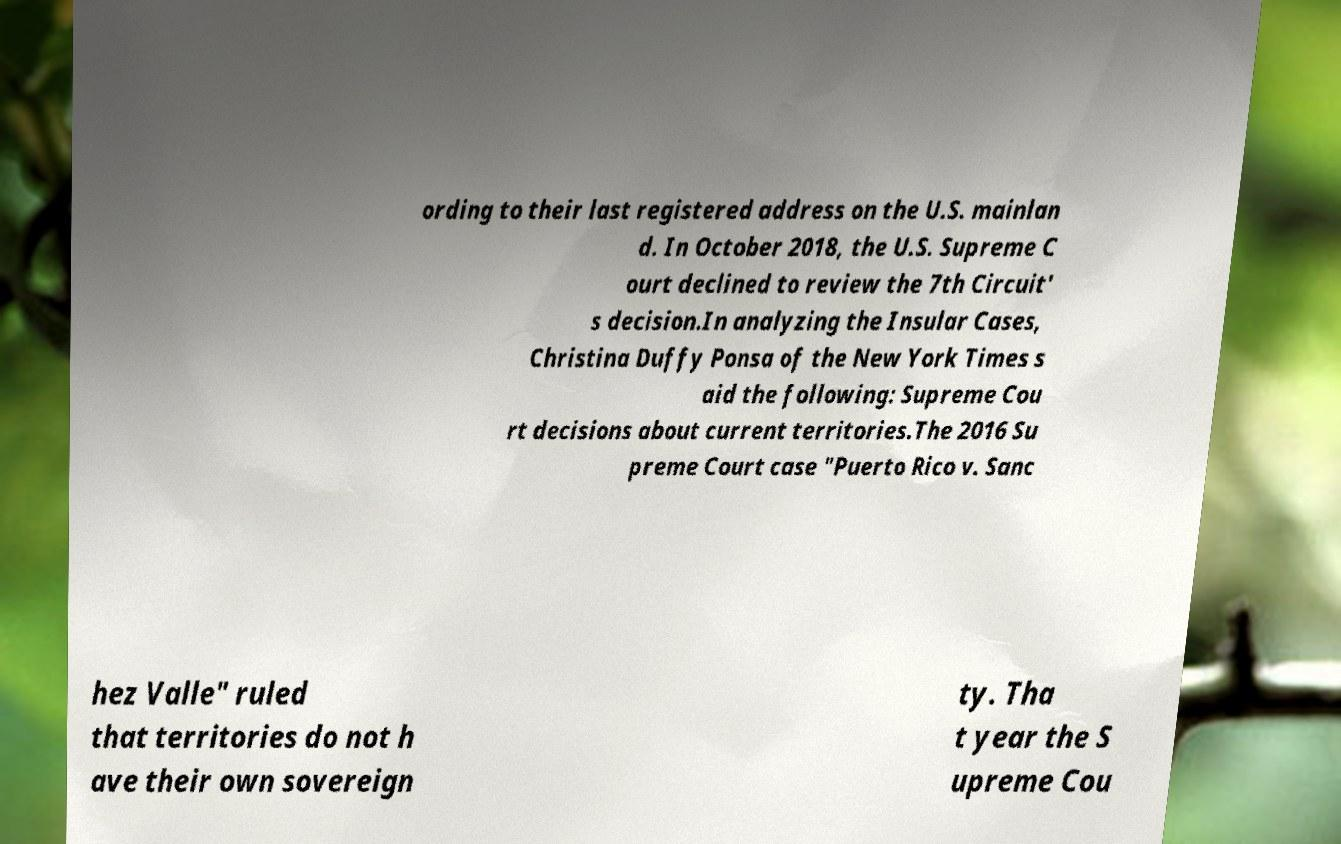Can you read and provide the text displayed in the image?This photo seems to have some interesting text. Can you extract and type it out for me? ording to their last registered address on the U.S. mainlan d. In October 2018, the U.S. Supreme C ourt declined to review the 7th Circuit' s decision.In analyzing the Insular Cases, Christina Duffy Ponsa of the New York Times s aid the following: Supreme Cou rt decisions about current territories.The 2016 Su preme Court case "Puerto Rico v. Sanc hez Valle" ruled that territories do not h ave their own sovereign ty. Tha t year the S upreme Cou 